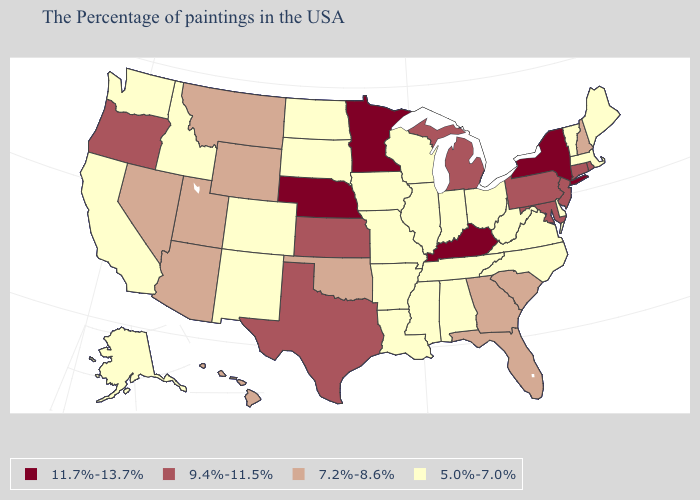Among the states that border Oklahoma , does Missouri have the lowest value?
Short answer required. Yes. Among the states that border Montana , does Wyoming have the lowest value?
Give a very brief answer. No. What is the value of Rhode Island?
Answer briefly. 9.4%-11.5%. Name the states that have a value in the range 5.0%-7.0%?
Give a very brief answer. Maine, Massachusetts, Vermont, Delaware, Virginia, North Carolina, West Virginia, Ohio, Indiana, Alabama, Tennessee, Wisconsin, Illinois, Mississippi, Louisiana, Missouri, Arkansas, Iowa, South Dakota, North Dakota, Colorado, New Mexico, Idaho, California, Washington, Alaska. Does Wisconsin have the same value as South Dakota?
Be succinct. Yes. Name the states that have a value in the range 7.2%-8.6%?
Short answer required. New Hampshire, South Carolina, Florida, Georgia, Oklahoma, Wyoming, Utah, Montana, Arizona, Nevada, Hawaii. Among the states that border Oklahoma , which have the highest value?
Quick response, please. Kansas, Texas. Name the states that have a value in the range 7.2%-8.6%?
Keep it brief. New Hampshire, South Carolina, Florida, Georgia, Oklahoma, Wyoming, Utah, Montana, Arizona, Nevada, Hawaii. What is the value of Arkansas?
Be succinct. 5.0%-7.0%. What is the value of Arizona?
Be succinct. 7.2%-8.6%. What is the value of Utah?
Concise answer only. 7.2%-8.6%. Name the states that have a value in the range 9.4%-11.5%?
Short answer required. Rhode Island, Connecticut, New Jersey, Maryland, Pennsylvania, Michigan, Kansas, Texas, Oregon. What is the value of New Mexico?
Answer briefly. 5.0%-7.0%. What is the value of Hawaii?
Keep it brief. 7.2%-8.6%. Name the states that have a value in the range 5.0%-7.0%?
Quick response, please. Maine, Massachusetts, Vermont, Delaware, Virginia, North Carolina, West Virginia, Ohio, Indiana, Alabama, Tennessee, Wisconsin, Illinois, Mississippi, Louisiana, Missouri, Arkansas, Iowa, South Dakota, North Dakota, Colorado, New Mexico, Idaho, California, Washington, Alaska. 